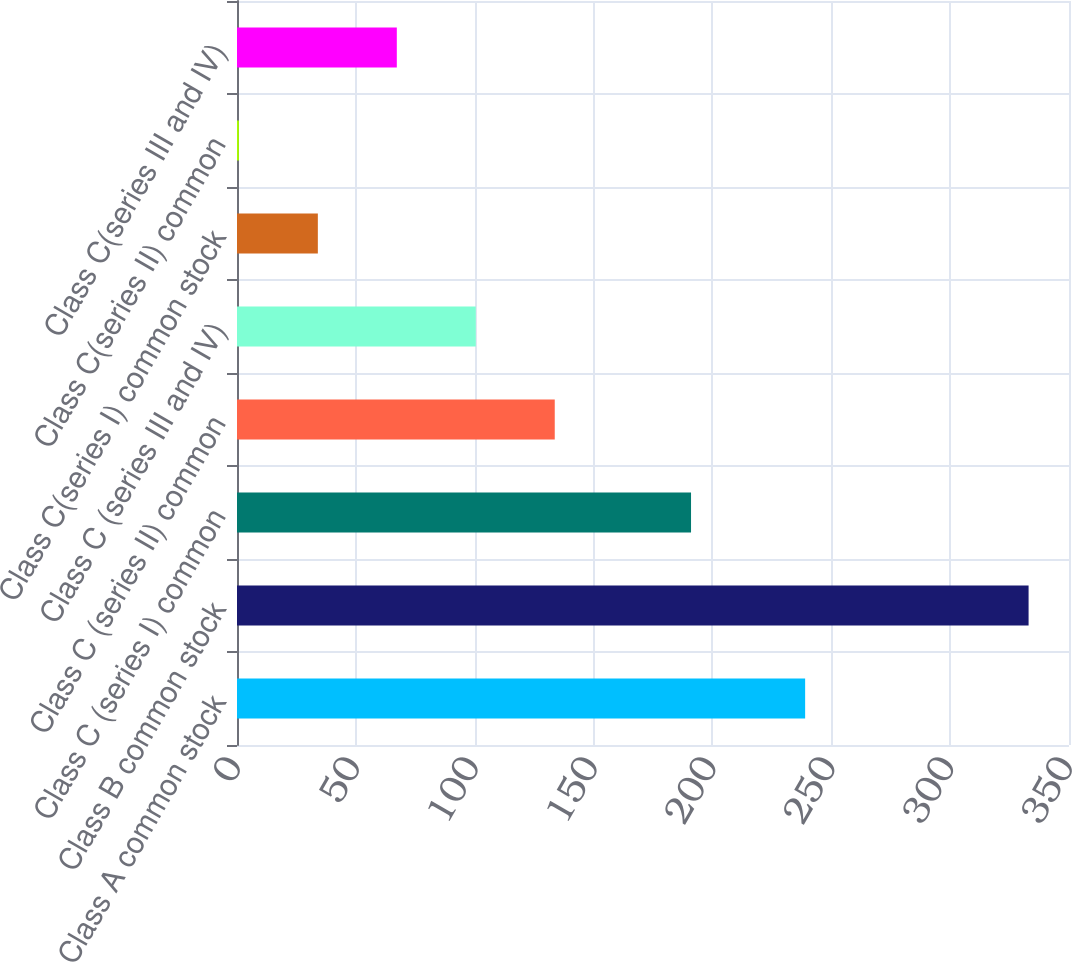<chart> <loc_0><loc_0><loc_500><loc_500><bar_chart><fcel>Class A common stock<fcel>Class B common stock<fcel>Class C (series I) common<fcel>Class C (series II) common<fcel>Class C (series III and IV)<fcel>Class C(series I) common stock<fcel>Class C(series II) common<fcel>Class C(series III and IV)<nl><fcel>239<fcel>333<fcel>191<fcel>133.67<fcel>100.45<fcel>34.01<fcel>0.79<fcel>67.23<nl></chart> 